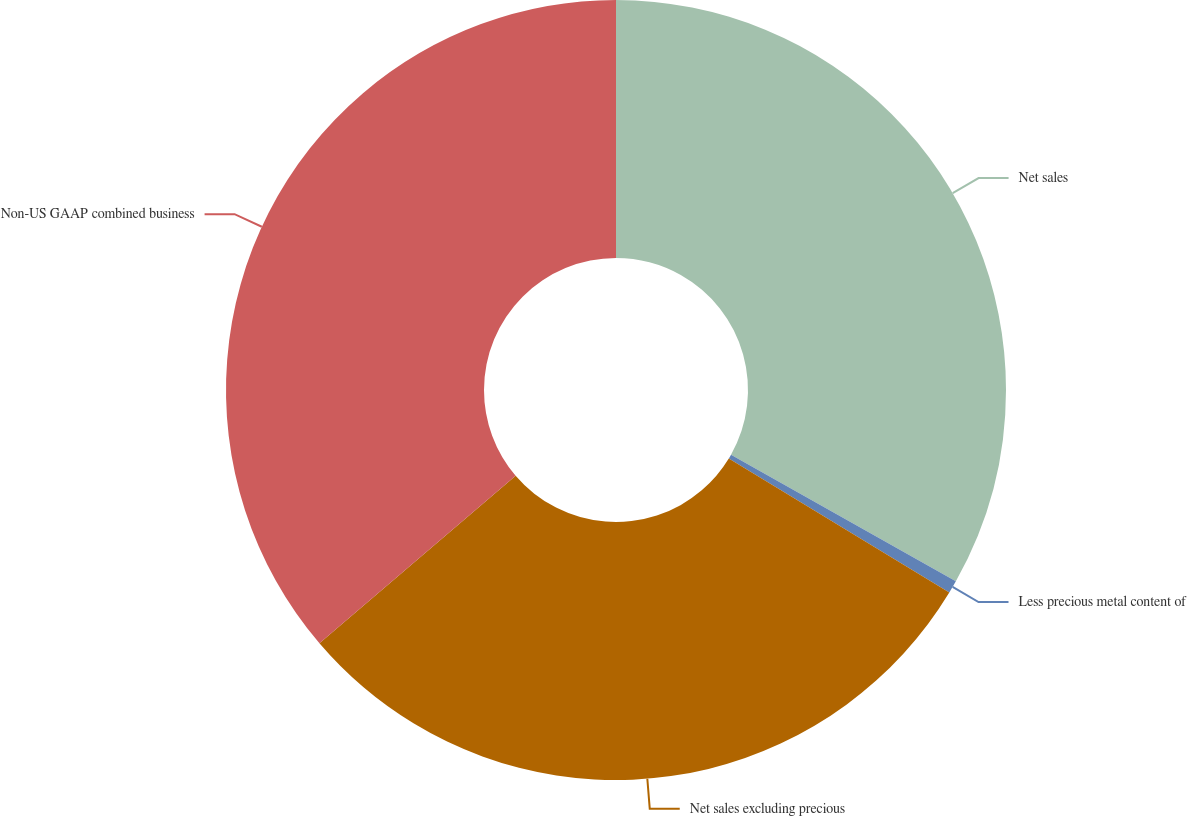<chart> <loc_0><loc_0><loc_500><loc_500><pie_chart><fcel>Net sales<fcel>Less precious metal content of<fcel>Net sales excluding precious<fcel>Non-US GAAP combined business<nl><fcel>33.16%<fcel>0.53%<fcel>30.06%<fcel>36.25%<nl></chart> 